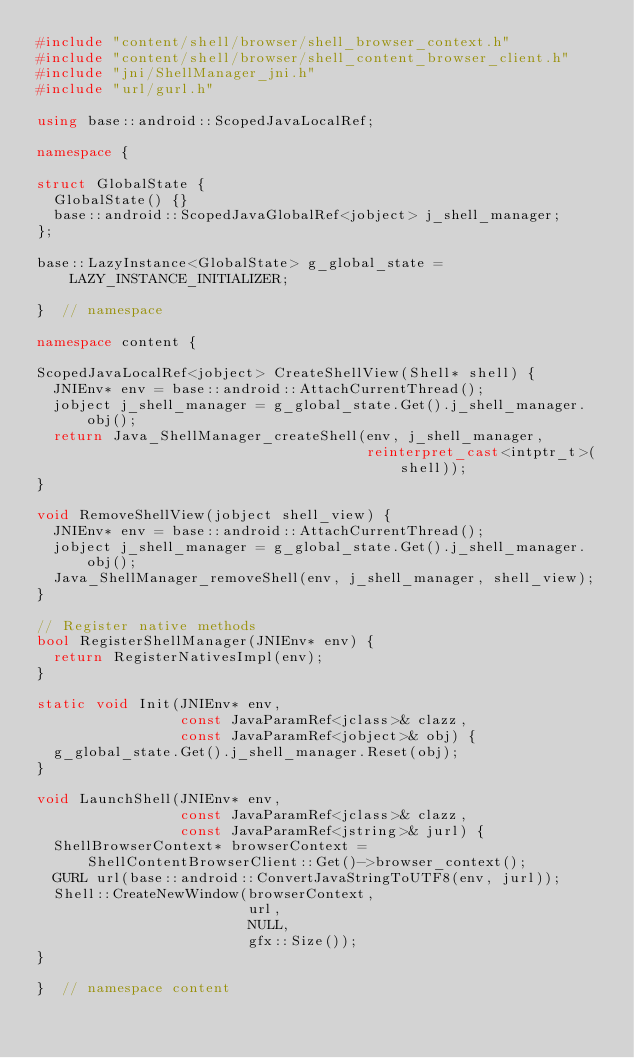<code> <loc_0><loc_0><loc_500><loc_500><_C++_>#include "content/shell/browser/shell_browser_context.h"
#include "content/shell/browser/shell_content_browser_client.h"
#include "jni/ShellManager_jni.h"
#include "url/gurl.h"

using base::android::ScopedJavaLocalRef;

namespace {

struct GlobalState {
  GlobalState() {}
  base::android::ScopedJavaGlobalRef<jobject> j_shell_manager;
};

base::LazyInstance<GlobalState> g_global_state = LAZY_INSTANCE_INITIALIZER;

}  // namespace

namespace content {

ScopedJavaLocalRef<jobject> CreateShellView(Shell* shell) {
  JNIEnv* env = base::android::AttachCurrentThread();
  jobject j_shell_manager = g_global_state.Get().j_shell_manager.obj();
  return Java_ShellManager_createShell(env, j_shell_manager,
                                       reinterpret_cast<intptr_t>(shell));
}

void RemoveShellView(jobject shell_view) {
  JNIEnv* env = base::android::AttachCurrentThread();
  jobject j_shell_manager = g_global_state.Get().j_shell_manager.obj();
  Java_ShellManager_removeShell(env, j_shell_manager, shell_view);
}

// Register native methods
bool RegisterShellManager(JNIEnv* env) {
  return RegisterNativesImpl(env);
}

static void Init(JNIEnv* env,
                 const JavaParamRef<jclass>& clazz,
                 const JavaParamRef<jobject>& obj) {
  g_global_state.Get().j_shell_manager.Reset(obj);
}

void LaunchShell(JNIEnv* env,
                 const JavaParamRef<jclass>& clazz,
                 const JavaParamRef<jstring>& jurl) {
  ShellBrowserContext* browserContext =
      ShellContentBrowserClient::Get()->browser_context();
  GURL url(base::android::ConvertJavaStringToUTF8(env, jurl));
  Shell::CreateNewWindow(browserContext,
                         url,
                         NULL,
                         gfx::Size());
}

}  // namespace content
</code> 